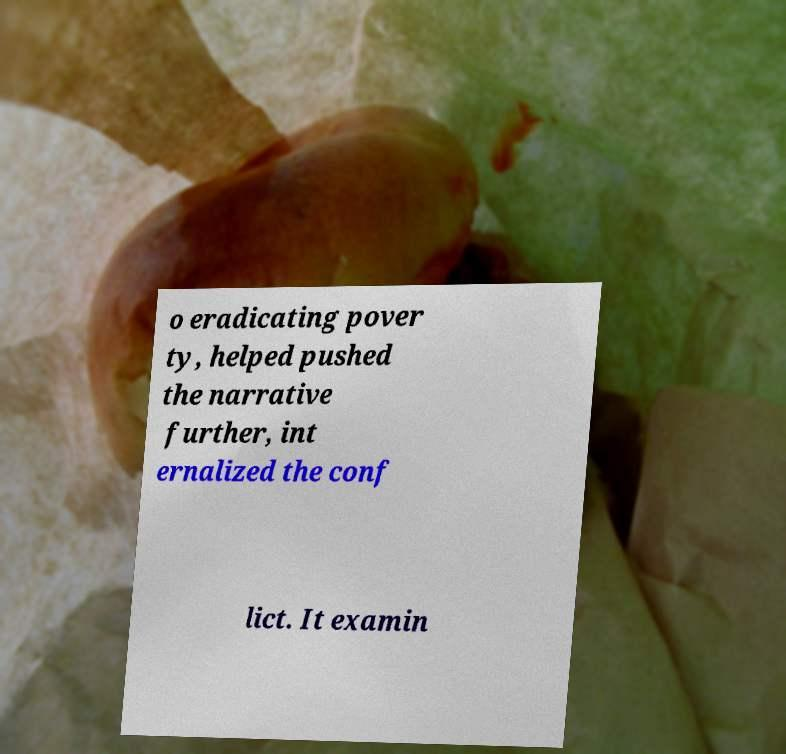I need the written content from this picture converted into text. Can you do that? o eradicating pover ty, helped pushed the narrative further, int ernalized the conf lict. It examin 